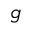<formula> <loc_0><loc_0><loc_500><loc_500>g</formula> 